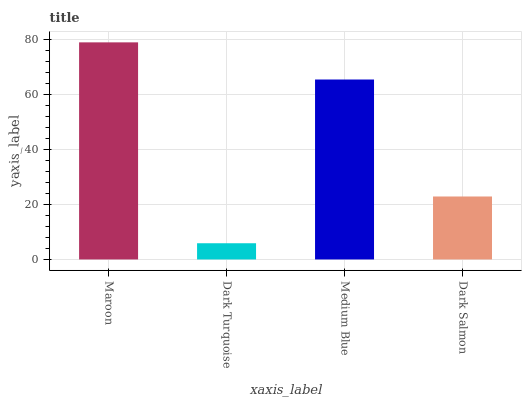Is Medium Blue the minimum?
Answer yes or no. No. Is Medium Blue the maximum?
Answer yes or no. No. Is Medium Blue greater than Dark Turquoise?
Answer yes or no. Yes. Is Dark Turquoise less than Medium Blue?
Answer yes or no. Yes. Is Dark Turquoise greater than Medium Blue?
Answer yes or no. No. Is Medium Blue less than Dark Turquoise?
Answer yes or no. No. Is Medium Blue the high median?
Answer yes or no. Yes. Is Dark Salmon the low median?
Answer yes or no. Yes. Is Dark Salmon the high median?
Answer yes or no. No. Is Maroon the low median?
Answer yes or no. No. 